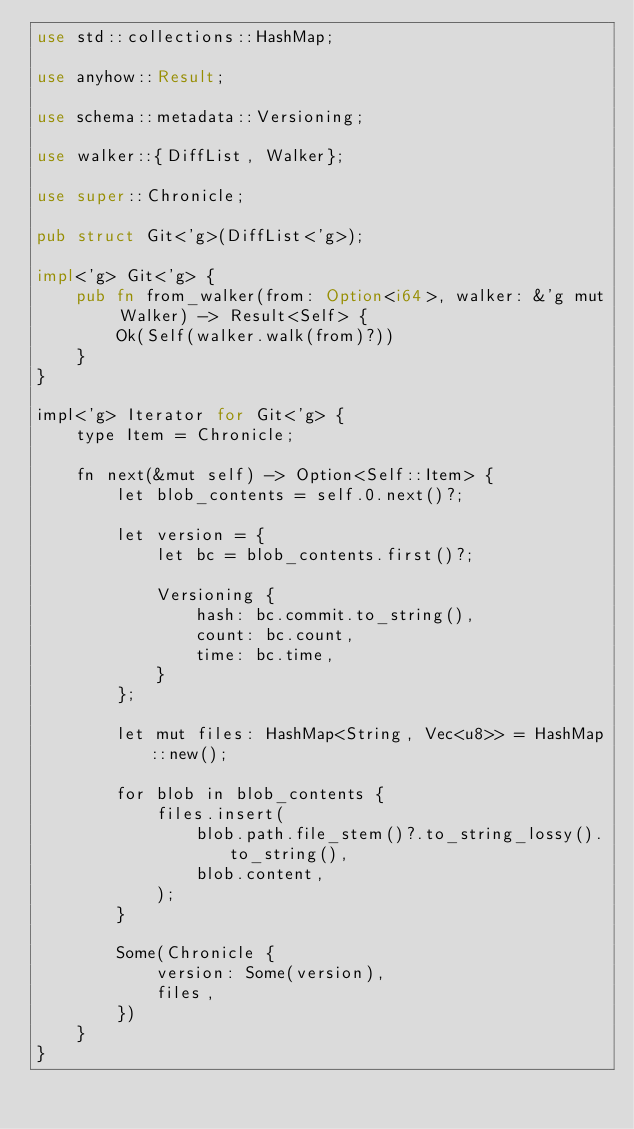<code> <loc_0><loc_0><loc_500><loc_500><_Rust_>use std::collections::HashMap;

use anyhow::Result;

use schema::metadata::Versioning;

use walker::{DiffList, Walker};

use super::Chronicle;

pub struct Git<'g>(DiffList<'g>);

impl<'g> Git<'g> {
    pub fn from_walker(from: Option<i64>, walker: &'g mut Walker) -> Result<Self> {
        Ok(Self(walker.walk(from)?))
    }
}

impl<'g> Iterator for Git<'g> {
    type Item = Chronicle;

    fn next(&mut self) -> Option<Self::Item> {
        let blob_contents = self.0.next()?;

        let version = {
            let bc = blob_contents.first()?;

            Versioning {
                hash: bc.commit.to_string(),
                count: bc.count,
                time: bc.time,
            }
        };

        let mut files: HashMap<String, Vec<u8>> = HashMap::new();

        for blob in blob_contents {
            files.insert(
                blob.path.file_stem()?.to_string_lossy().to_string(),
                blob.content,
            );
        }

        Some(Chronicle {
            version: Some(version),
            files,
        })
    }
}
</code> 